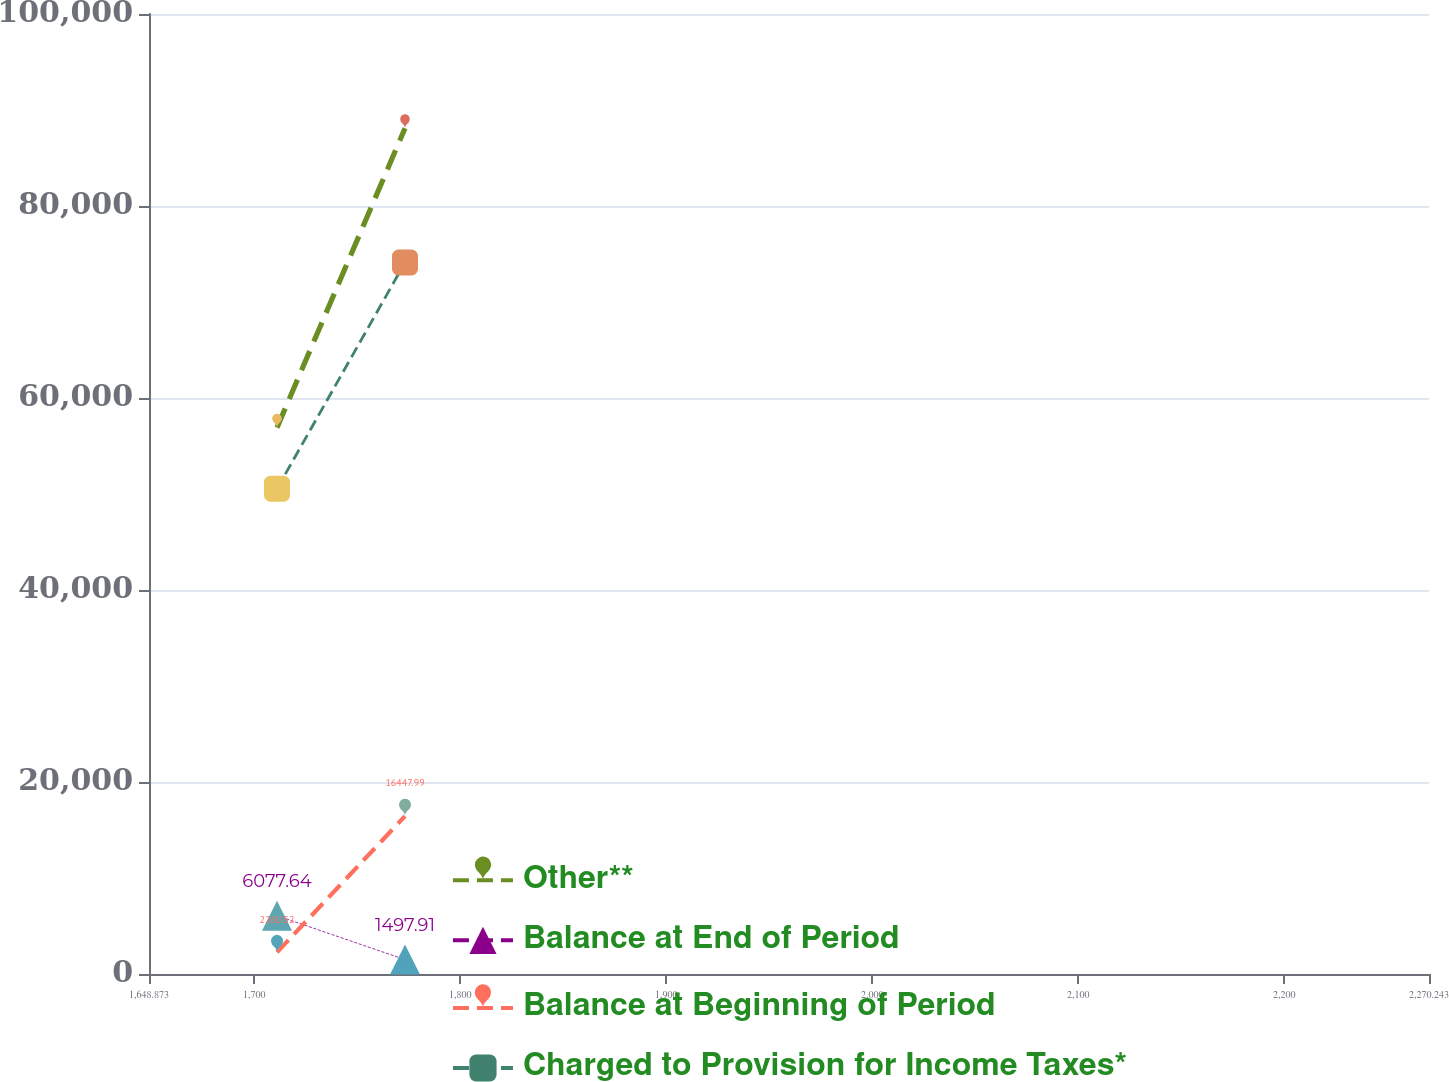Convert chart. <chart><loc_0><loc_0><loc_500><loc_500><line_chart><ecel><fcel>Other**<fcel>Balance at End of Period<fcel>Balance at Beginning of Period<fcel>Charged to Provision for Income Taxes*<nl><fcel>1711.01<fcel>56916.1<fcel>6077.64<fcel>2260.52<fcel>50551.2<nl><fcel>1773.15<fcel>88100.6<fcel>1497.91<fcel>16448<fcel>74113.4<nl><fcel>2332.38<fcel>99851.6<fcel>1955.88<fcel>11373.4<fcel>95267.6<nl></chart> 